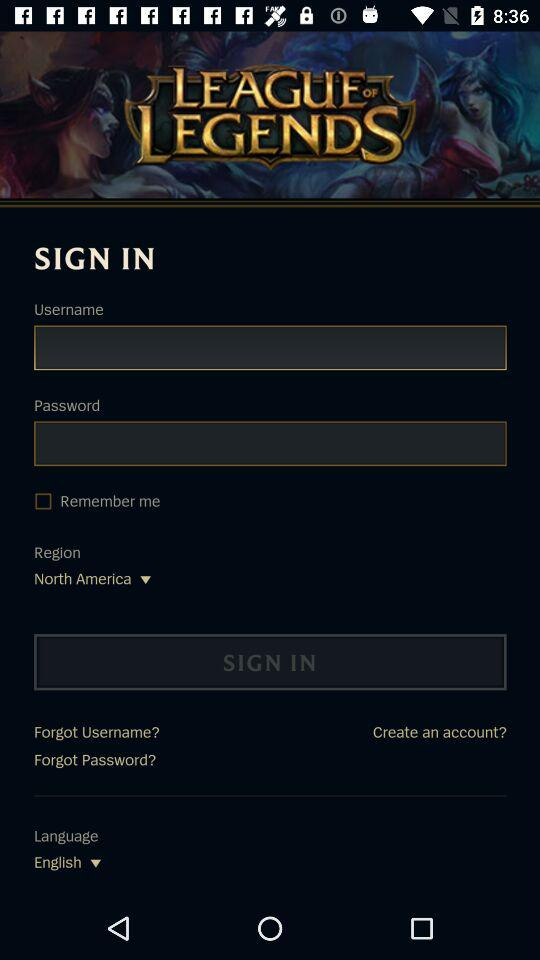What is the status of "Remember me"? The status is "off". 